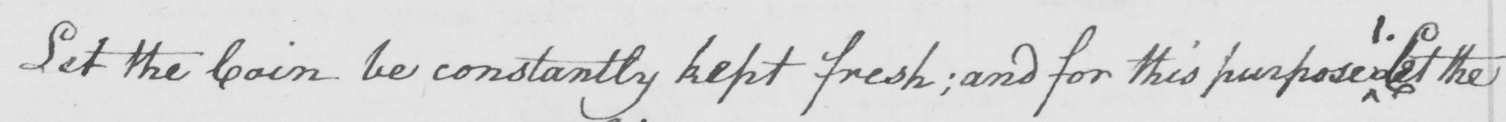What text is written in this handwritten line? Let the coin be constantly kept fresh  ; and for this purpose Let the 